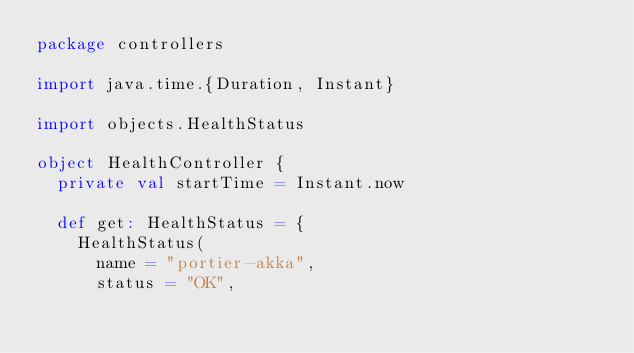Convert code to text. <code><loc_0><loc_0><loc_500><loc_500><_Scala_>package controllers

import java.time.{Duration, Instant}

import objects.HealthStatus

object HealthController {
  private val startTime = Instant.now

  def get: HealthStatus = {
    HealthStatus(
      name = "portier-akka",
      status = "OK",</code> 